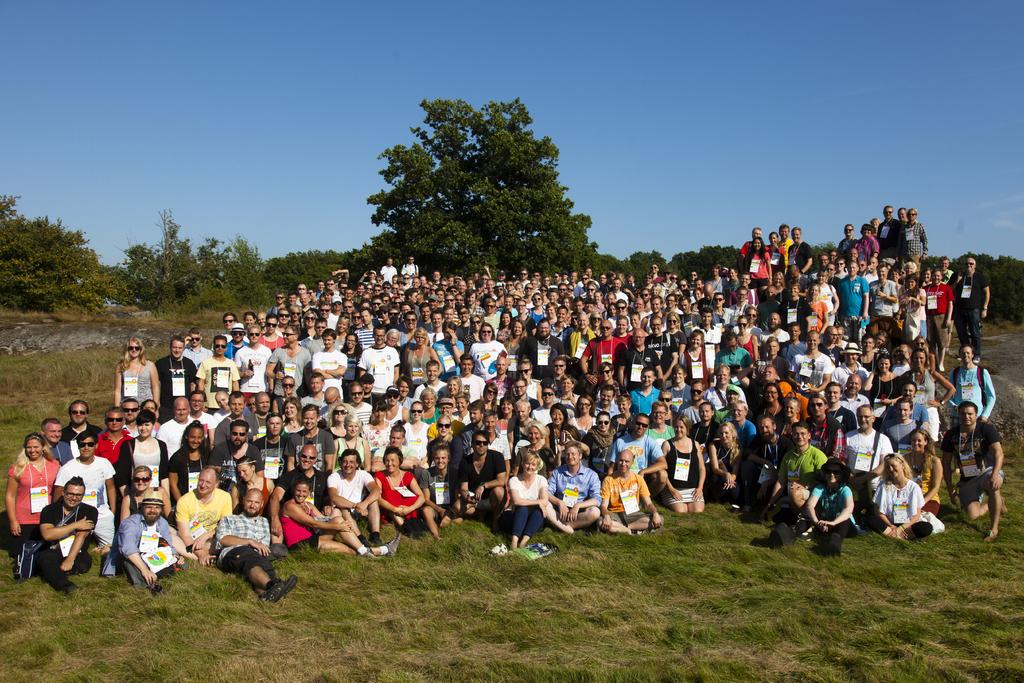How many people are in the image? There is a group of people in the image, but the exact number is not specified. What are the people in the image doing? Some people are standing, while others are sitting. What type of terrain is visible in the image? There is grass in the image. What can be seen in the background of the image? There are trees with branches and leaves in the leaves in the image, and the sky is visible. What type of treatment is being administered to the trees in the image? There is no indication in the image that any treatment is being administered to the trees; they appear to be healthy and growing naturally. What sound can be heard coming from the people in the image? The image is silent, so no sound can be heard from the people or any other elements in the image. 